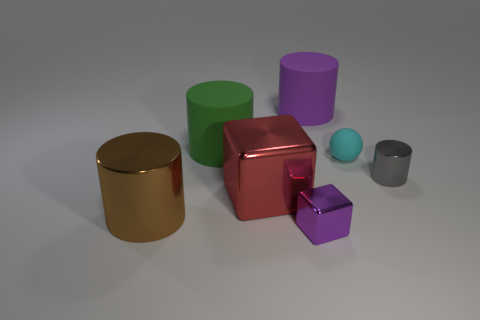How many metallic objects are either large brown cylinders or cubes?
Keep it short and to the point. 3. There is a large matte thing that is the same color as the small cube; what shape is it?
Provide a succinct answer. Cylinder. What is the purple thing on the right side of the small purple cube made of?
Your response must be concise. Rubber. What number of things are green cubes or things in front of the green cylinder?
Offer a terse response. 5. There is a purple rubber thing that is the same size as the green object; what shape is it?
Your answer should be very brief. Cylinder. How many matte objects are the same color as the large metallic cube?
Offer a terse response. 0. Is the tiny object right of the tiny cyan object made of the same material as the brown cylinder?
Your response must be concise. Yes. The large purple object is what shape?
Make the answer very short. Cylinder. How many purple things are rubber cylinders or big metal cubes?
Make the answer very short. 1. How many other objects are the same material as the green cylinder?
Your answer should be very brief. 2. 